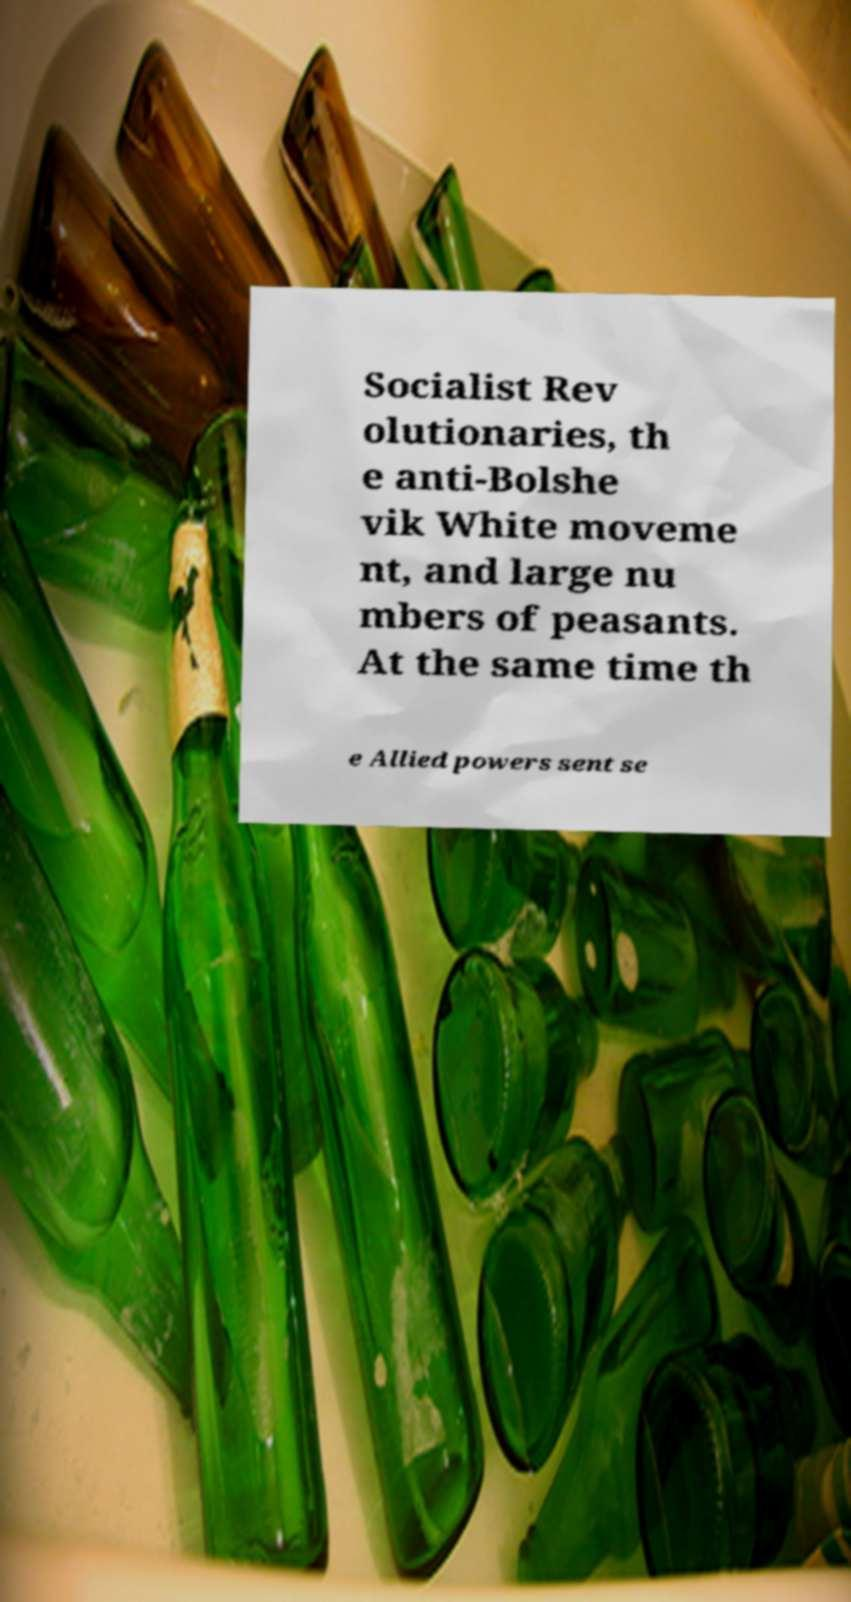There's text embedded in this image that I need extracted. Can you transcribe it verbatim? Socialist Rev olutionaries, th e anti-Bolshe vik White moveme nt, and large nu mbers of peasants. At the same time th e Allied powers sent se 